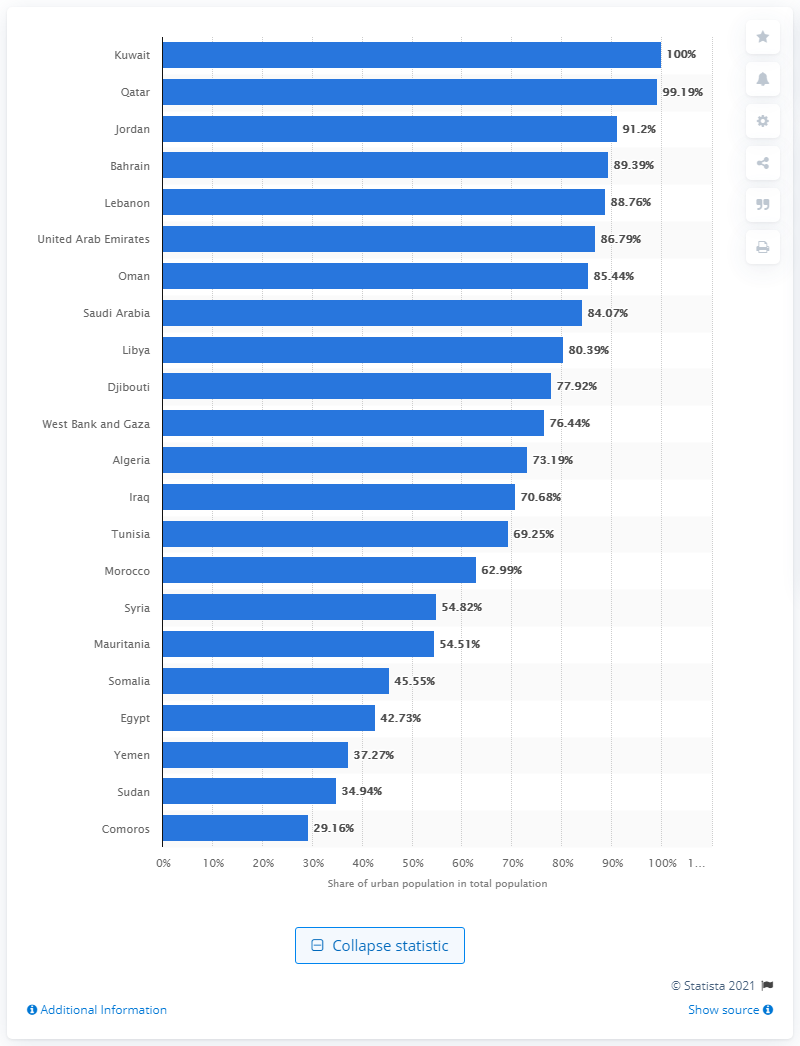Draw attention to some important aspects in this diagram. According to the given information, the highest percentage of a country's population living in urban areas is in Algeria, where 73.19% of the population resides in urban areas. 